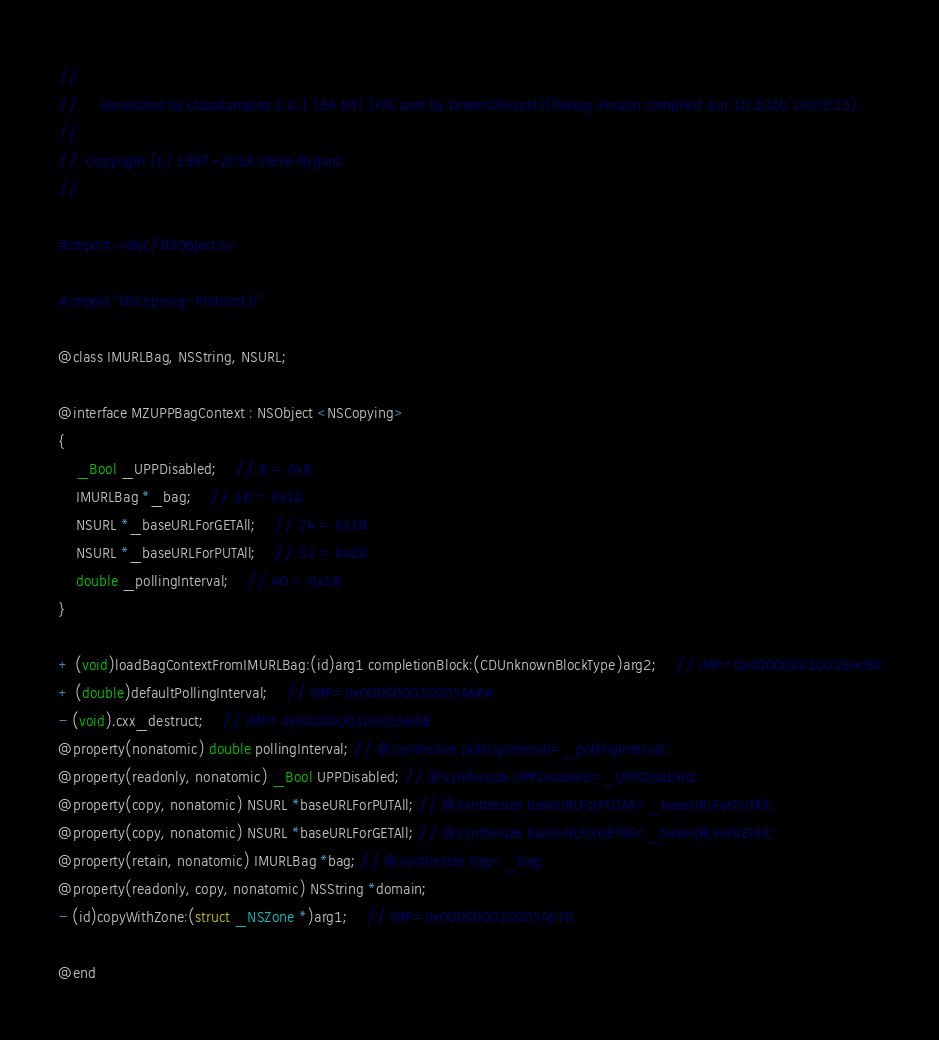Convert code to text. <code><loc_0><loc_0><loc_500><loc_500><_C_>//
//     Generated by classdumpios 1.0.1 (64 bit) (iOS port by DreamDevLost)(Debug version compiled Jun 10 2020 10:03:13).
//
//  Copyright (C) 1997-2019 Steve Nygard.
//

#import <objc/NSObject.h>

#import "NSCopying-Protocol.h"

@class IMURLBag, NSString, NSURL;

@interface MZUPPBagContext : NSObject <NSCopying>
{
    _Bool _UPPDisabled;	// 8 = 0x8
    IMURLBag *_bag;	// 16 = 0x10
    NSURL *_baseURLForGETAll;	// 24 = 0x18
    NSURL *_baseURLForPUTAll;	// 32 = 0x20
    double _pollingInterval;	// 40 = 0x28
}

+ (void)loadBagContextFromIMURLBag:(id)arg1 completionBlock:(CDUnknownBlockType)arg2;	// IMP=0x0000000100054c90
+ (double)defaultPollingInterval;	// IMP=0x0000000100054b64
- (void).cxx_destruct;	// IMP=0x0000000100055868
@property(nonatomic) double pollingInterval; // @synthesize pollingInterval=_pollingInterval;
@property(readonly, nonatomic) _Bool UPPDisabled; // @synthesize UPPDisabled=_UPPDisabled;
@property(copy, nonatomic) NSURL *baseURLForPUTAll; // @synthesize baseURLForPUTAll=_baseURLForPUTAll;
@property(copy, nonatomic) NSURL *baseURLForGETAll; // @synthesize baseURLForGETAll=_baseURLForGETAll;
@property(retain, nonatomic) IMURLBag *bag; // @synthesize bag=_bag;
@property(readonly, copy, nonatomic) NSString *domain;
- (id)copyWithZone:(struct _NSZone *)arg1;	// IMP=0x0000000100054b70

@end

</code> 